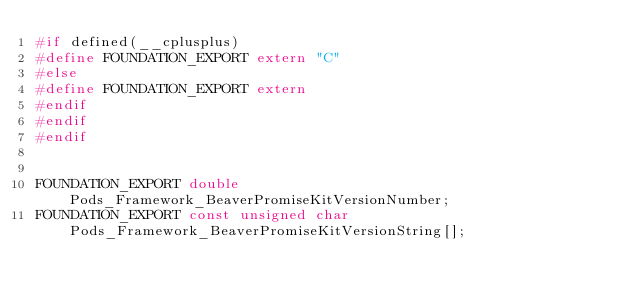Convert code to text. <code><loc_0><loc_0><loc_500><loc_500><_C_>#if defined(__cplusplus)
#define FOUNDATION_EXPORT extern "C"
#else
#define FOUNDATION_EXPORT extern
#endif
#endif
#endif


FOUNDATION_EXPORT double Pods_Framework_BeaverPromiseKitVersionNumber;
FOUNDATION_EXPORT const unsigned char Pods_Framework_BeaverPromiseKitVersionString[];

</code> 